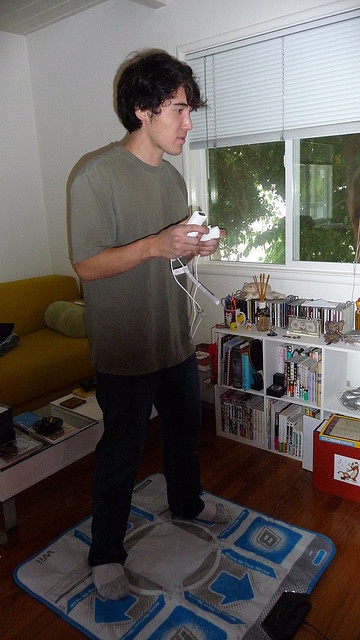<image>What kind of blinds are on the window? I'm not sure about the kind of blinds on the window. It could be venetian blinds, vinyl blinds, wood, or mini blinds. What kind of blinds are on the window? I am not sure what kind of blinds are on the window. It can be seen 'white', 'venetian blinds', 'vinyl blinds', 'wood', or 'mini blinds'. 